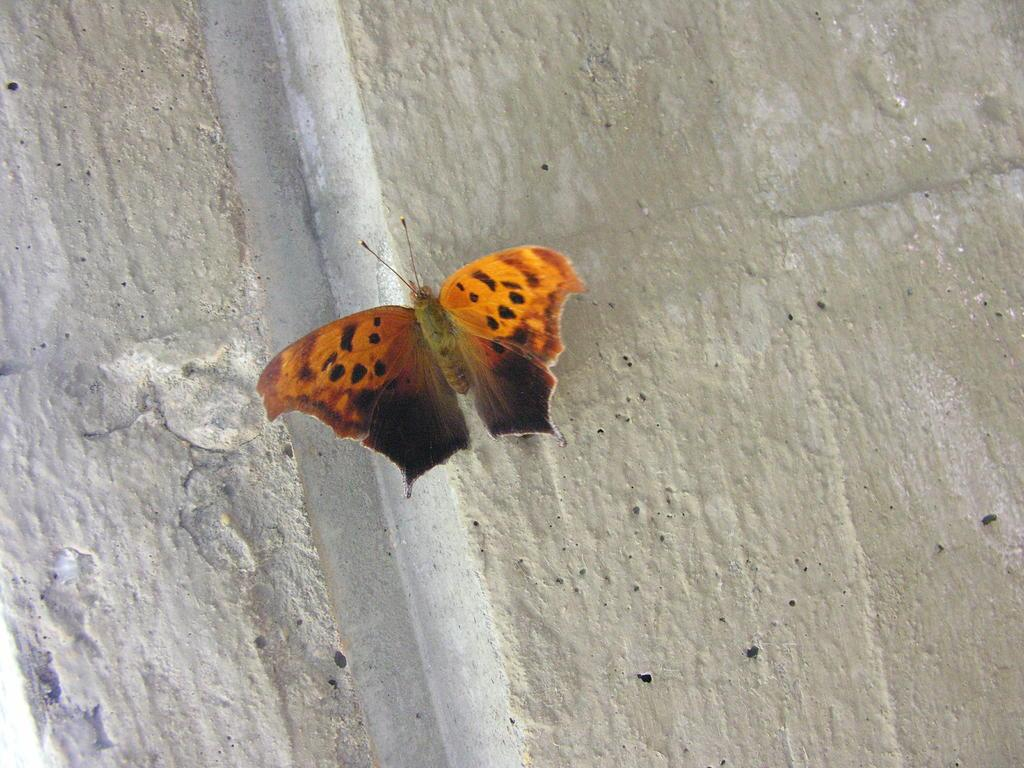What is the main subject of the picture? The main subject of the picture is a butterfly. Can you describe the colors of the butterfly? The butterfly has black and orange colors. Where is the butterfly located in the picture? The butterfly is on the wall. What type of jar can be seen in the picture? There is no jar present in the picture; it features a butterfly on the wall. How many years has the butterfly been living in the cave? There is no cave or mention of time in the picture, so it is not possible to determine how long the butterfly has been living there. 